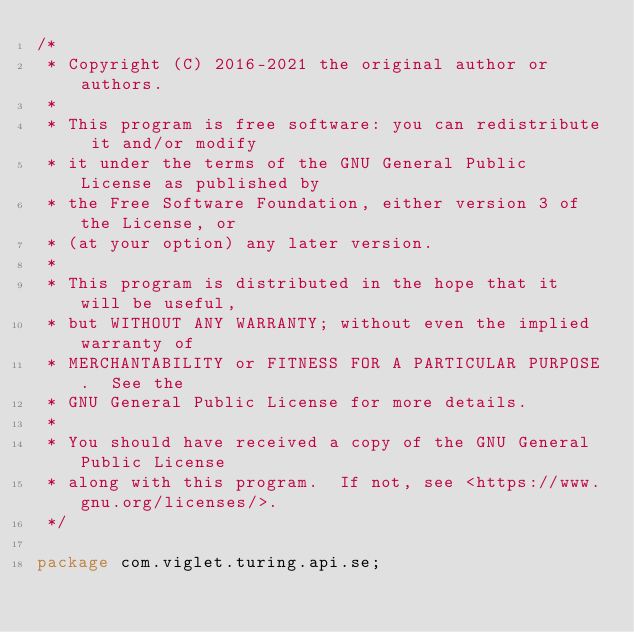Convert code to text. <code><loc_0><loc_0><loc_500><loc_500><_Java_>/*
 * Copyright (C) 2016-2021 the original author or authors. 
 * 
 * This program is free software: you can redistribute it and/or modify
 * it under the terms of the GNU General Public License as published by
 * the Free Software Foundation, either version 3 of the License, or
 * (at your option) any later version.
 *
 * This program is distributed in the hope that it will be useful,
 * but WITHOUT ANY WARRANTY; without even the implied warranty of
 * MERCHANTABILITY or FITNESS FOR A PARTICULAR PURPOSE.  See the
 * GNU General Public License for more details.
 *
 * You should have received a copy of the GNU General Public License
 * along with this program.  If not, see <https://www.gnu.org/licenses/>.
 */

package com.viglet.turing.api.se;
</code> 